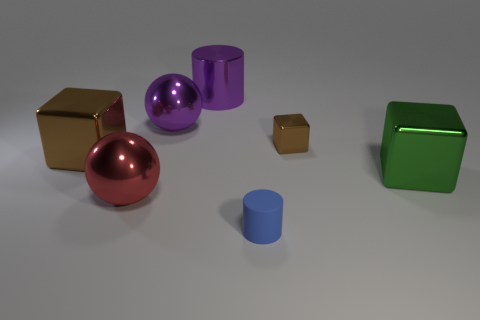Add 1 rubber things. How many objects exist? 8 Subtract all cylinders. How many objects are left? 5 Add 3 purple spheres. How many purple spheres are left? 4 Add 5 cubes. How many cubes exist? 8 Subtract 0 green cylinders. How many objects are left? 7 Subtract all brown cubes. Subtract all red spheres. How many objects are left? 4 